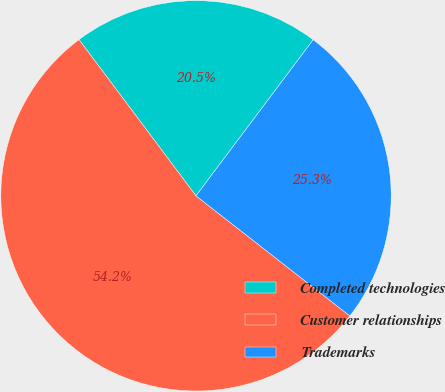Convert chart. <chart><loc_0><loc_0><loc_500><loc_500><pie_chart><fcel>Completed technologies<fcel>Customer relationships<fcel>Trademarks<nl><fcel>20.48%<fcel>54.22%<fcel>25.3%<nl></chart> 